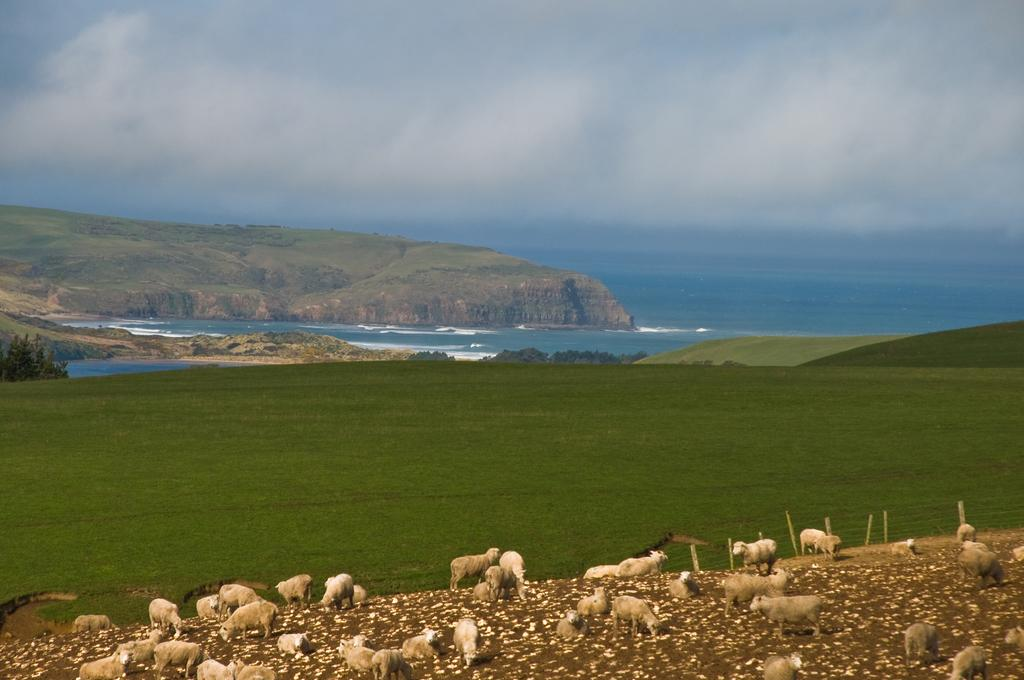What type of animals can be seen in the image? There are sheep in the image. What is on the ground in the image? There is grass on the ground in the image. What other natural elements are present in the image? There are trees and water visible in the image. How would you describe the sky in the image? The sky is blue and cloudy in the image. What type of nut is being cracked by the cows in the image? There are no cows or nuts present in the image; it features sheep, grass, trees, water, and a blue, cloudy sky. 